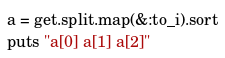<code> <loc_0><loc_0><loc_500><loc_500><_Ruby_>a = get.split.map(&:to_i).sort
puts "a[0] a[1] a[2]"</code> 